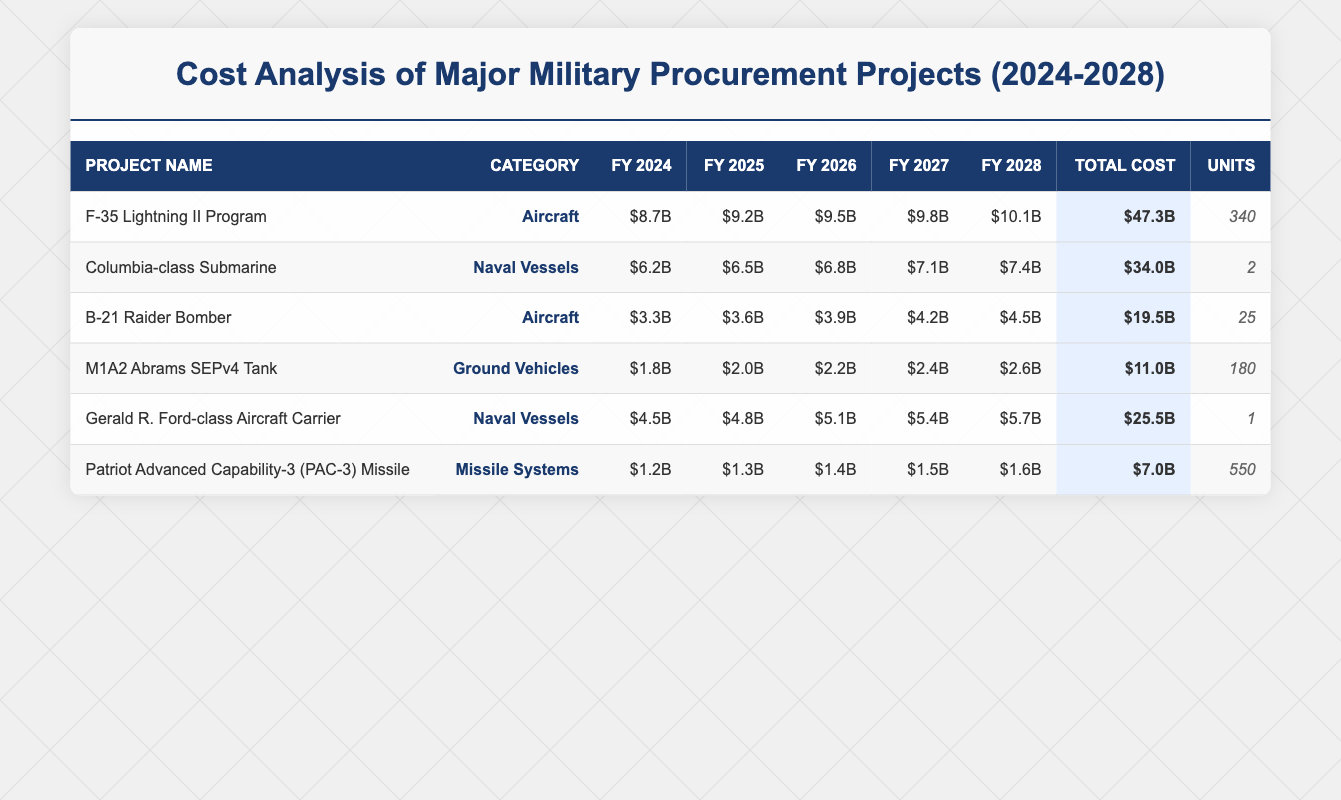What is the total cost of the F-35 Lightning II Program? The total cost for the F-35 Lightning II Program is provided in the table under the 'Total Cost' column. It is listed as $47.3B.
Answer: $47.3B How many units of the Gerald R. Ford-class Aircraft Carrier are being procured? The number of units procured for the Gerald R. Ford-class Aircraft Carrier is found in the 'Units' column of the table, which shows 1 unit.
Answer: 1 What is the total cost of all missile systems combined? The total cost of missile systems is found by focusing on the 'Total Cost' for the Patriot Advanced Capability-3 (PAC-3) Missile, which is $7.0B. There is only one missile system in the table, so its total cost is $7.0B.
Answer: $7.0B Which project has the highest annual cost in fiscal year 2028? In fiscal year 2028, the costs are listed for all projects. The costs are: F-35 Lightning II Program $10.1B, Columbia-class Submarine $7.4B, B-21 Raider Bomber $4.5B, M1A2 Abrams SEPv4 Tank $2.6B, Gerald R. Ford-class Aircraft Carrier $5.7B, and PAC-3 Missile $1.6B. The highest amount among these is $10.1B for the F-35 Lightning II Program.
Answer: F-35 Lightning II Program If you combine the total costs of B-21 Raider Bomber and M1A2 Abrams SEPv4 Tank, what would that amount be? The total costs of the B-21 Raider Bomber and M1A2 Abrams SEPv4 Tank are $19.5B and $11.0B, respectively. To find the combined total, we add these amounts together: $19.5B + $11.0B = $30.5B.
Answer: $30.5B Is the total cost of the Columbia-class Submarine less than $35B? The total cost for the Columbia-class Submarine is $34.0B, which is indeed less than $35B. Thus, the answer is yes.
Answer: Yes How much more is the total cost of the F-35 Lightning II Program compared to the B-21 Raider Bomber? The total cost of the F-35 Lightning II Program is $47.3B, while the B-21 Raider Bomber's total cost is $19.5B. To find the difference, we subtract the cost of the B-21 Raider Bomber from that of the F-35: $47.3B - $19.5B = $27.8B.
Answer: $27.8B Which category has the greatest total cost across all projects? To find the category with the greatest total cost, we must look at the total costs for each category: Aircraft (F-35 and B-21; $47.3B + $19.5B = $66.8B), Naval Vessels (Columbia-class and Gerald R. Ford-class; $34.0B + $25.5B = $59.5B), Ground Vehicles (M1A2 Abrams; $11.0B), and Missile Systems (PAC-3; $7.0B). The greatest total cost comes from the Aircraft category with $66.8B.
Answer: Aircraft 